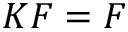Convert formula to latex. <formula><loc_0><loc_0><loc_500><loc_500>K F = F</formula> 